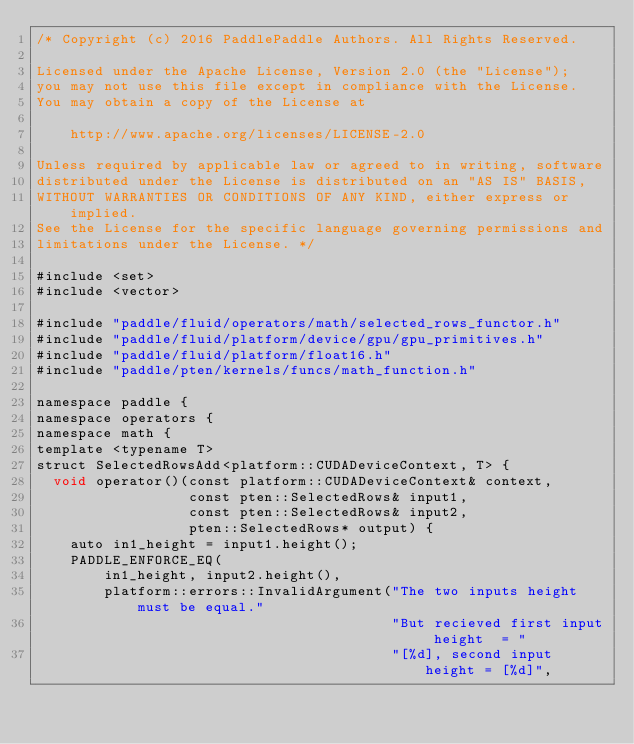<code> <loc_0><loc_0><loc_500><loc_500><_Cuda_>/* Copyright (c) 2016 PaddlePaddle Authors. All Rights Reserved.

Licensed under the Apache License, Version 2.0 (the "License");
you may not use this file except in compliance with the License.
You may obtain a copy of the License at

    http://www.apache.org/licenses/LICENSE-2.0

Unless required by applicable law or agreed to in writing, software
distributed under the License is distributed on an "AS IS" BASIS,
WITHOUT WARRANTIES OR CONDITIONS OF ANY KIND, either express or implied.
See the License for the specific language governing permissions and
limitations under the License. */

#include <set>
#include <vector>

#include "paddle/fluid/operators/math/selected_rows_functor.h"
#include "paddle/fluid/platform/device/gpu/gpu_primitives.h"
#include "paddle/fluid/platform/float16.h"
#include "paddle/pten/kernels/funcs/math_function.h"

namespace paddle {
namespace operators {
namespace math {
template <typename T>
struct SelectedRowsAdd<platform::CUDADeviceContext, T> {
  void operator()(const platform::CUDADeviceContext& context,
                  const pten::SelectedRows& input1,
                  const pten::SelectedRows& input2,
                  pten::SelectedRows* output) {
    auto in1_height = input1.height();
    PADDLE_ENFORCE_EQ(
        in1_height, input2.height(),
        platform::errors::InvalidArgument("The two inputs height must be equal."
                                          "But recieved first input height  = "
                                          "[%d], second input height = [%d]",</code> 